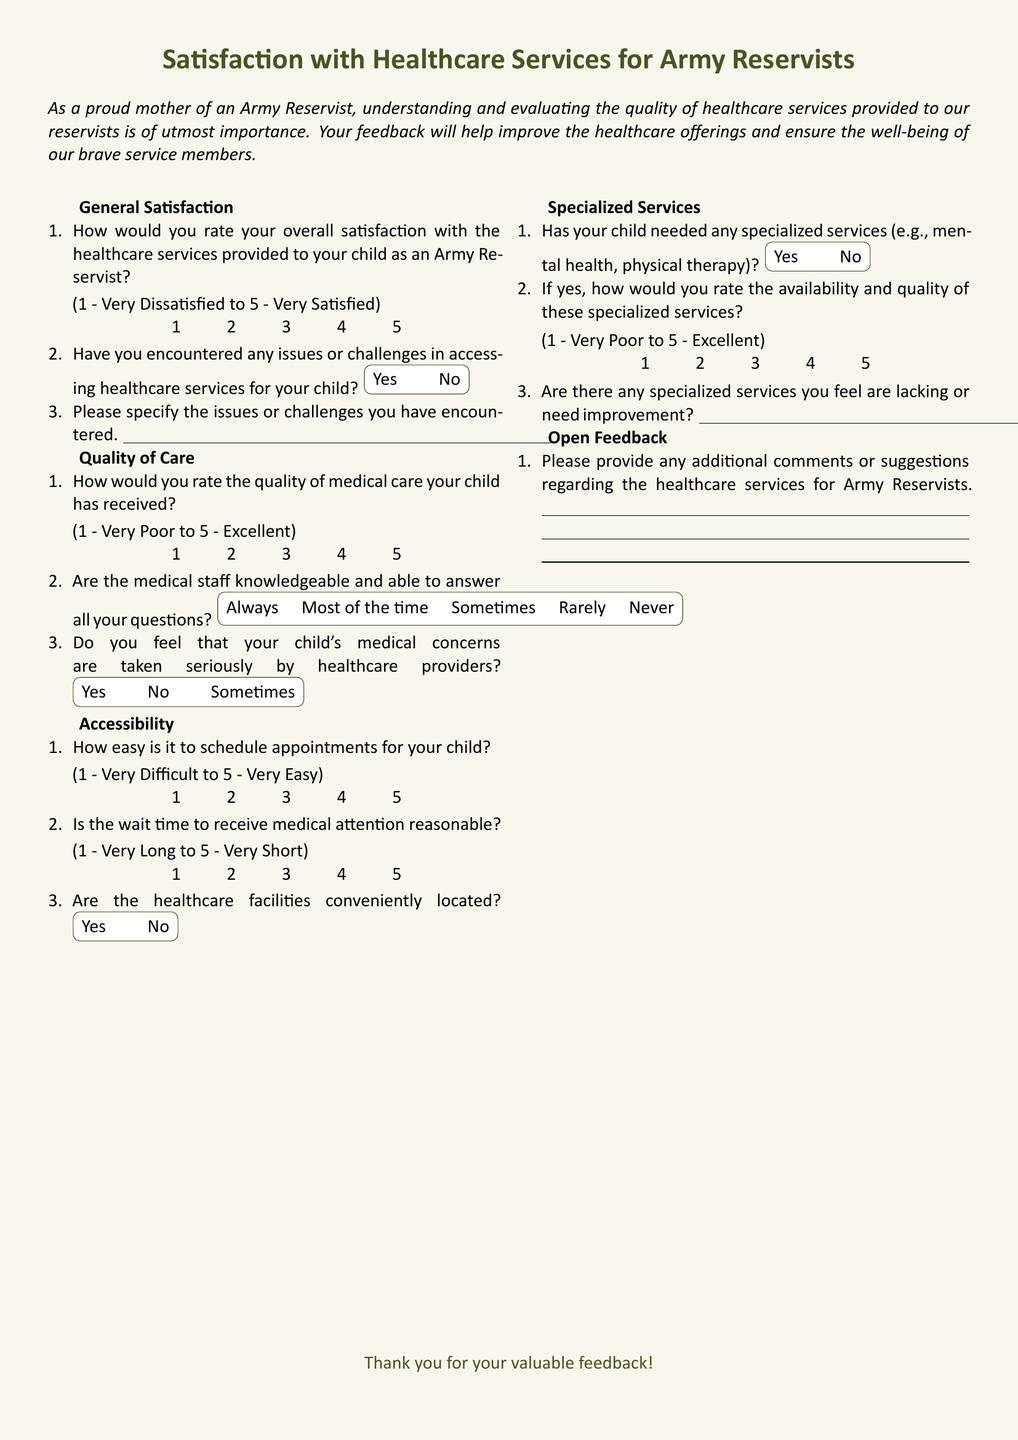What is the main purpose of the survey? The main purpose is to understand and evaluate the quality of healthcare services provided to Army Reservists and to improve offerings based on feedback.
Answer: Understanding and evaluating healthcare quality How many sections are in the survey? The survey consists of four main sections: General Satisfaction, Quality of Care, Accessibility, and Specialized Services.
Answer: Four sections What rating scale is used for overall satisfaction? The overall satisfaction is rated on a scale from 1 to 5, where 1 is "Very Dissatisfied" and 5 is "Very Satisfied."
Answer: 1 to 5 What is the color used for the title? The title is colored in army green.
Answer: Army green Are there any open feedback questions? Yes, there is a section for additional comments or suggestions regarding healthcare services.
Answer: Yes What response options are provided for feedback on the quality of medical care? Respondents are provided with options ranging from 1 (Very Poor) to 5 (Excellent).
Answer: 1 to 5 Is there a question about the reasonableness of wait times? Yes, there is a question asking respondents to rate whether the wait time to receive medical attention is reasonable.
Answer: Yes What are the response options for scheduling appointments? Respondents rate the ease of scheduling appointments on a scale from 1 (Very Difficult) to 5 (Very Easy).
Answer: 1 to 5 Does the survey inquire about specialized services? Yes, there is a question about whether the child has needed specialized services.
Answer: Yes 